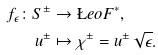Convert formula to latex. <formula><loc_0><loc_0><loc_500><loc_500>f _ { \epsilon } \colon S ^ { \pm } & \to \L e o F ^ { * } , \\ u ^ { \pm } & \mapsto \chi ^ { \pm } = u ^ { \pm } \sqrt { \epsilon } .</formula> 